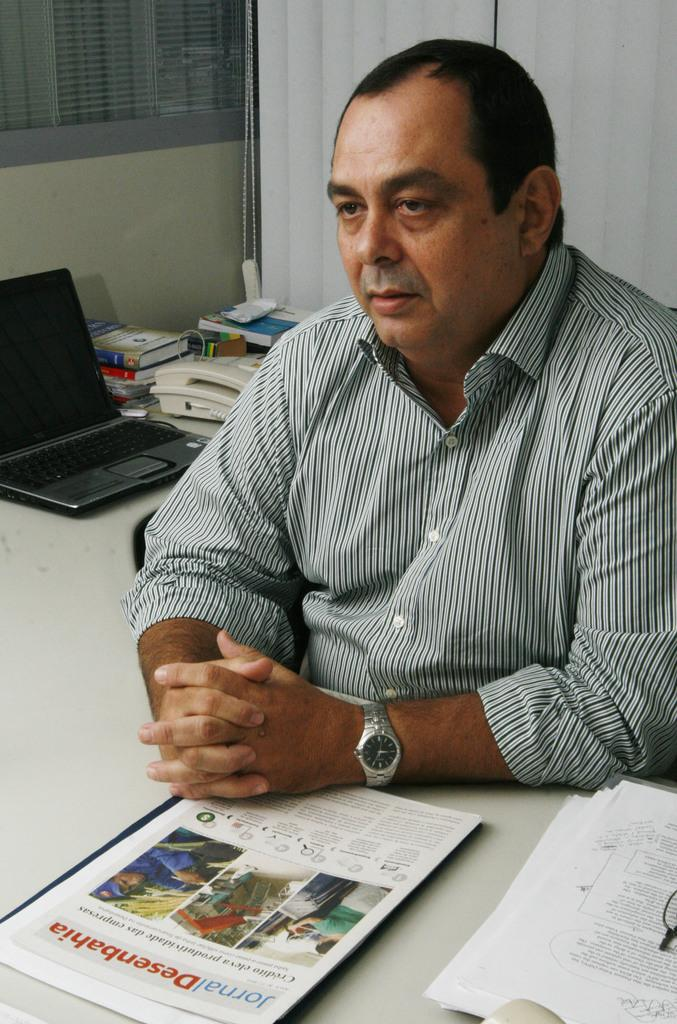Provide a one-sentence caption for the provided image. Man with a booklet in front of him that says "Desenbahia". 